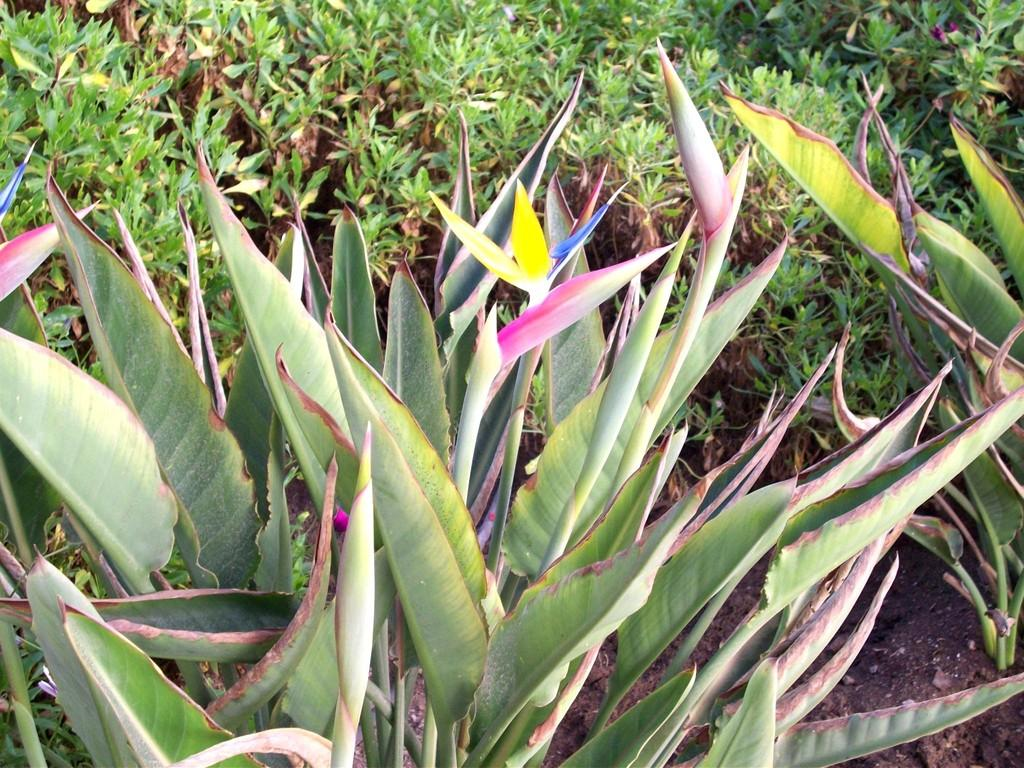What type of living organisms can be seen in the image? Plants can be seen in the image. What part of the natural environment is visible in the image? The ground is visible in the image. What type of pies are being served in the image? There are no pies present in the image. What time of day is depicted in the image? The time of day is not mentioned or depicted in the image. 